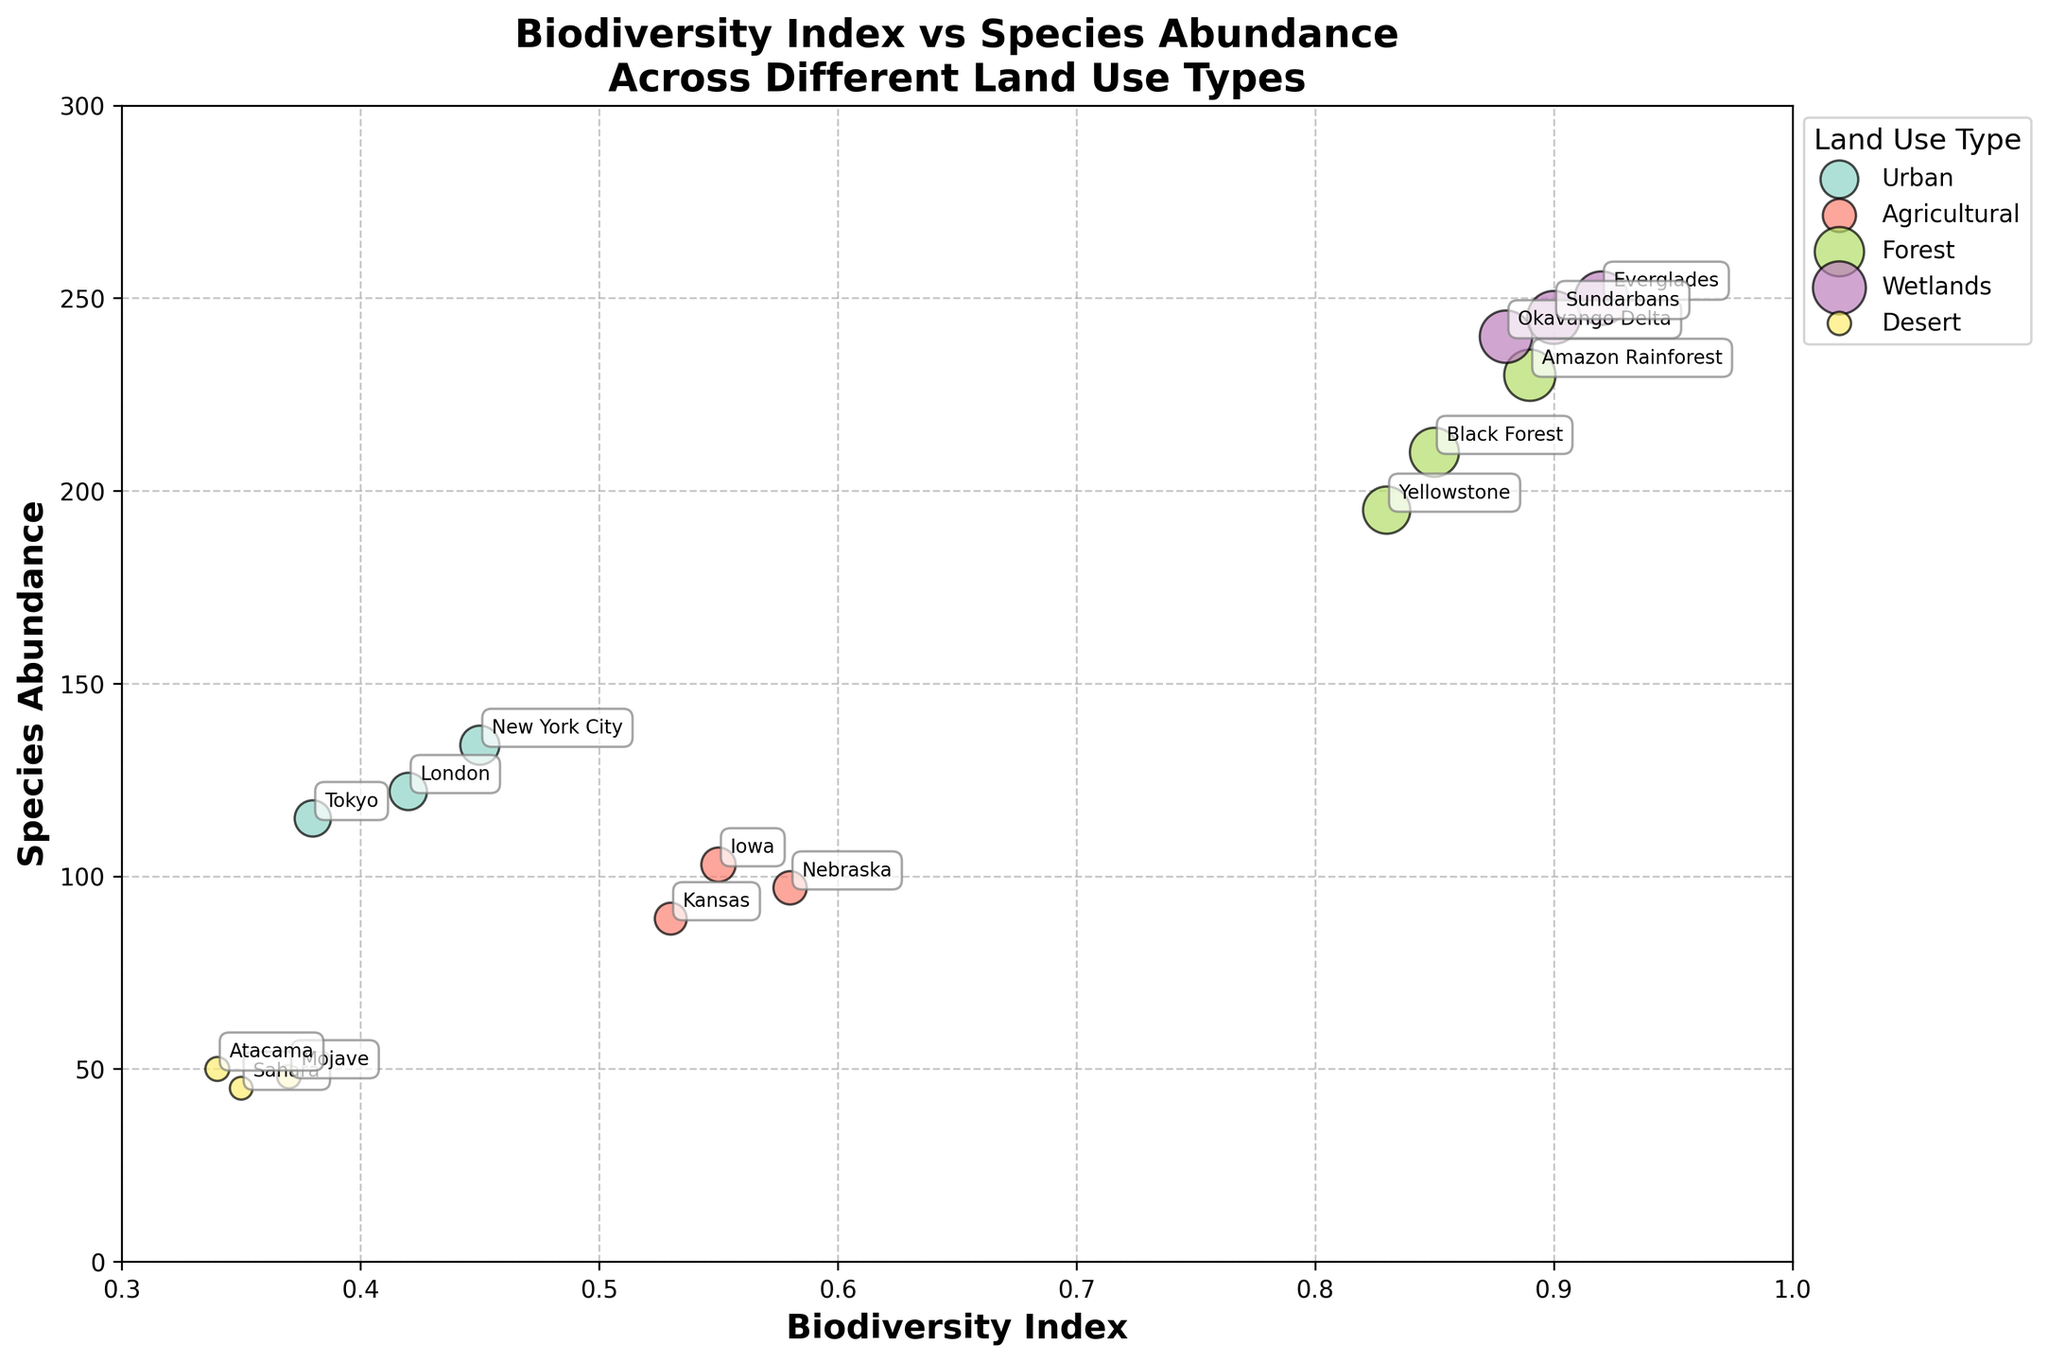What is the title of the plot? The title can be found at the top of the plot and it summarizes the main focus of the figure.
Answer: Biodiversity Index vs Species Abundance Across Different Land Use Types How many land use types are depicted in the plot? By checking the unique legend entries, each color represents a different land use type. Counting them gives the total number of land use types.
Answer: 5 Which region has the highest biodiversity index among the urban areas? Locate the urban data points and identify the highest value on the biodiversity index axis. The region label next to this point indicates the region with the highest index.
Answer: New York City What is the range of species abundance values for the forest land use type? Identify the species abundance values for the forest category by finding the forest points in the plot and noting their species abundance values. Calculate the range by subtracting the smallest value from the largest value.
Answer: 230 - 195 = 35 Which land use type displays the highest biodiversity index on average? Calculate the average biodiversity index for each land use type by summing the biodiversity index values and dividing by the number of data points per land use type. The highest result indicates the land use type with the highest average biodiversity index.
Answer: Wetlands What can be inferred about the biodiversity index and species abundance trend for desert regions? Locate the data points for desert regions and observe the trend of the biodiversity index and species abundance. Describe the noticeable pattern or correlation if it exists.
Answer: Low biodiversity index and low species abundance Compare the species abundance in the Amazon Rainforest and the Black Forest. Which one is higher, and by how much? Identify the species abundance values for both the Amazon Rainforest and the Black Forest and subtract the smaller value from the larger value to find the difference.
Answer: Amazon Rainforest is higher by 20 What pattern can you observe between biodiversity index and species abundance across different land use types? Observe the overall distribution of points across the different land use types to identify any general trend, such as a correlation or clustering pattern.
Answer: Forests and wetlands show higher biodiversity index and species abundance; deserts show both lower Is there a land use type where all regions have a biodiversity index below 0.5? If yes, which one? Check the biodiversity index for each region within each land use type to see if all values under a particular type are below 0.5.
Answer: Urban Which region has the highest species abundance in the dataset, and what is its biodiversity index? Locate the largest bubble (highest species abundance) in the plot and note its biodiversity index value and the corresponding region label.
Answer: Everglades, with biodiversity index 0.92 